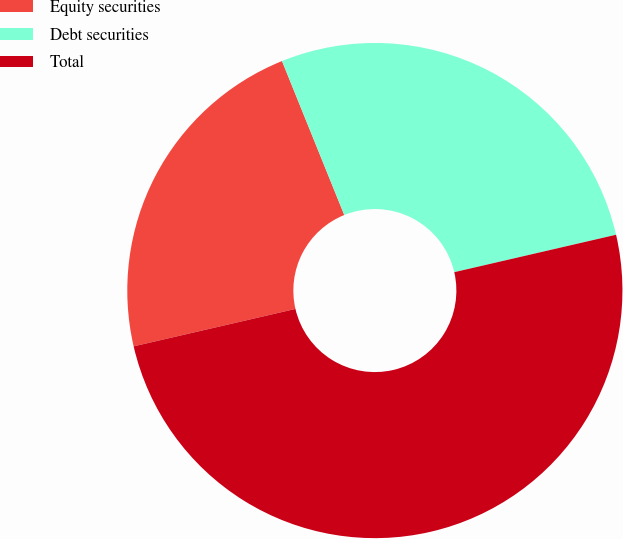Convert chart. <chart><loc_0><loc_0><loc_500><loc_500><pie_chart><fcel>Equity securities<fcel>Debt securities<fcel>Total<nl><fcel>22.5%<fcel>27.5%<fcel>50.0%<nl></chart> 